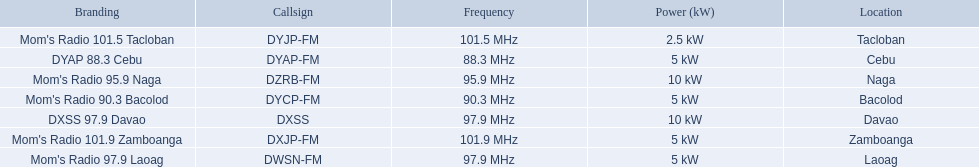What are the frequencies for radios of dyap-fm? 97.9 MHz, 95.9 MHz, 90.3 MHz, 88.3 MHz, 101.5 MHz, 101.9 MHz, 97.9 MHz. What is the lowest frequency? 88.3 MHz. Which radio has this frequency? DYAP 88.3 Cebu. 